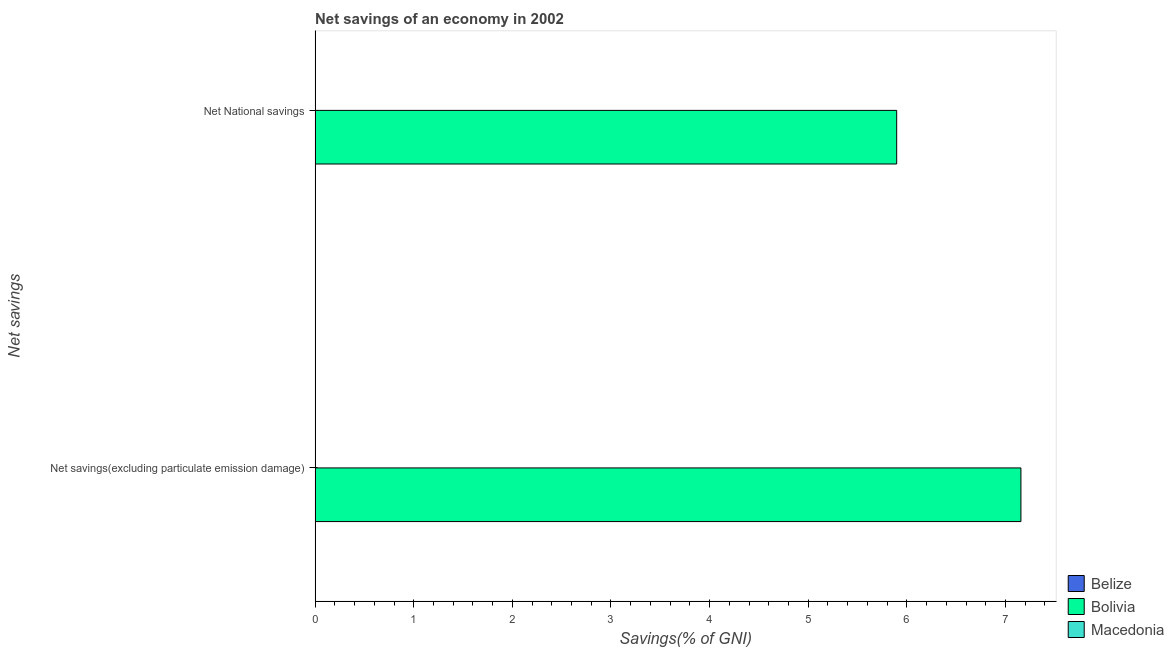Are the number of bars on each tick of the Y-axis equal?
Your answer should be very brief. Yes. How many bars are there on the 2nd tick from the top?
Provide a succinct answer. 1. How many bars are there on the 1st tick from the bottom?
Provide a succinct answer. 1. What is the label of the 2nd group of bars from the top?
Your answer should be very brief. Net savings(excluding particulate emission damage). What is the net savings(excluding particulate emission damage) in Belize?
Your answer should be compact. 0. Across all countries, what is the maximum net savings(excluding particulate emission damage)?
Your answer should be compact. 7.16. Across all countries, what is the minimum net savings(excluding particulate emission damage)?
Offer a terse response. 0. In which country was the net national savings maximum?
Make the answer very short. Bolivia. What is the total net national savings in the graph?
Provide a short and direct response. 5.9. What is the difference between the net national savings in Bolivia and the net savings(excluding particulate emission damage) in Belize?
Ensure brevity in your answer.  5.9. What is the average net national savings per country?
Your response must be concise. 1.97. What is the difference between the net savings(excluding particulate emission damage) and net national savings in Bolivia?
Keep it short and to the point. 1.26. In how many countries, is the net national savings greater than 7.2 %?
Offer a terse response. 0. How many bars are there?
Keep it short and to the point. 2. What is the difference between two consecutive major ticks on the X-axis?
Your answer should be very brief. 1. Does the graph contain any zero values?
Provide a short and direct response. Yes. Does the graph contain grids?
Your answer should be compact. No. Where does the legend appear in the graph?
Provide a short and direct response. Bottom right. How many legend labels are there?
Offer a terse response. 3. What is the title of the graph?
Your answer should be compact. Net savings of an economy in 2002. Does "Channel Islands" appear as one of the legend labels in the graph?
Your answer should be very brief. No. What is the label or title of the X-axis?
Provide a succinct answer. Savings(% of GNI). What is the label or title of the Y-axis?
Provide a succinct answer. Net savings. What is the Savings(% of GNI) in Bolivia in Net savings(excluding particulate emission damage)?
Ensure brevity in your answer.  7.16. What is the Savings(% of GNI) in Bolivia in Net National savings?
Offer a terse response. 5.9. Across all Net savings, what is the maximum Savings(% of GNI) of Bolivia?
Offer a terse response. 7.16. Across all Net savings, what is the minimum Savings(% of GNI) in Bolivia?
Offer a terse response. 5.9. What is the total Savings(% of GNI) in Bolivia in the graph?
Provide a succinct answer. 13.05. What is the total Savings(% of GNI) of Macedonia in the graph?
Keep it short and to the point. 0. What is the difference between the Savings(% of GNI) in Bolivia in Net savings(excluding particulate emission damage) and that in Net National savings?
Ensure brevity in your answer.  1.26. What is the average Savings(% of GNI) of Belize per Net savings?
Offer a very short reply. 0. What is the average Savings(% of GNI) in Bolivia per Net savings?
Provide a short and direct response. 6.53. What is the ratio of the Savings(% of GNI) of Bolivia in Net savings(excluding particulate emission damage) to that in Net National savings?
Your response must be concise. 1.21. What is the difference between the highest and the second highest Savings(% of GNI) in Bolivia?
Provide a succinct answer. 1.26. What is the difference between the highest and the lowest Savings(% of GNI) in Bolivia?
Your answer should be compact. 1.26. 